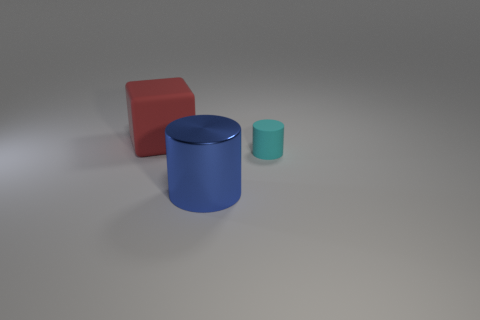The big thing that is the same material as the small cylinder is what color?
Make the answer very short. Red. Is the size of the matte thing on the right side of the block the same as the blue cylinder?
Keep it short and to the point. No. What number of objects are small cylinders or rubber objects?
Offer a very short reply. 2. What material is the cylinder that is left of the rubber thing in front of the object that is behind the tiny cyan cylinder?
Provide a succinct answer. Metal. What is the cylinder that is behind the big blue object made of?
Ensure brevity in your answer.  Rubber. Are there any gray cylinders of the same size as the shiny object?
Your answer should be compact. No. There is a rubber thing that is behind the small cyan rubber cylinder; is it the same color as the tiny rubber cylinder?
Your response must be concise. No. What number of brown objects are big metal things or cylinders?
Provide a succinct answer. 0. How many cubes have the same color as the small matte object?
Your response must be concise. 0. Are the large block and the cyan cylinder made of the same material?
Provide a succinct answer. Yes. 